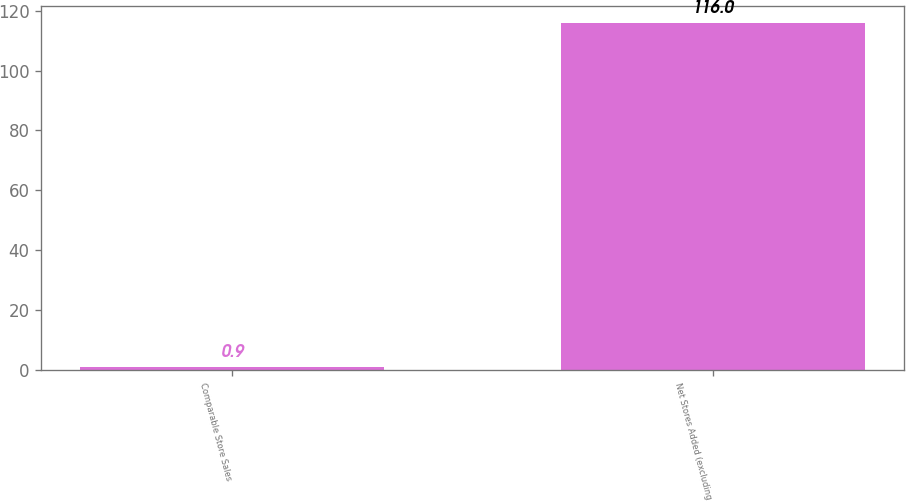Convert chart to OTSL. <chart><loc_0><loc_0><loc_500><loc_500><bar_chart><fcel>Comparable Store Sales<fcel>Net Stores Added (excluding<nl><fcel>0.9<fcel>116<nl></chart> 